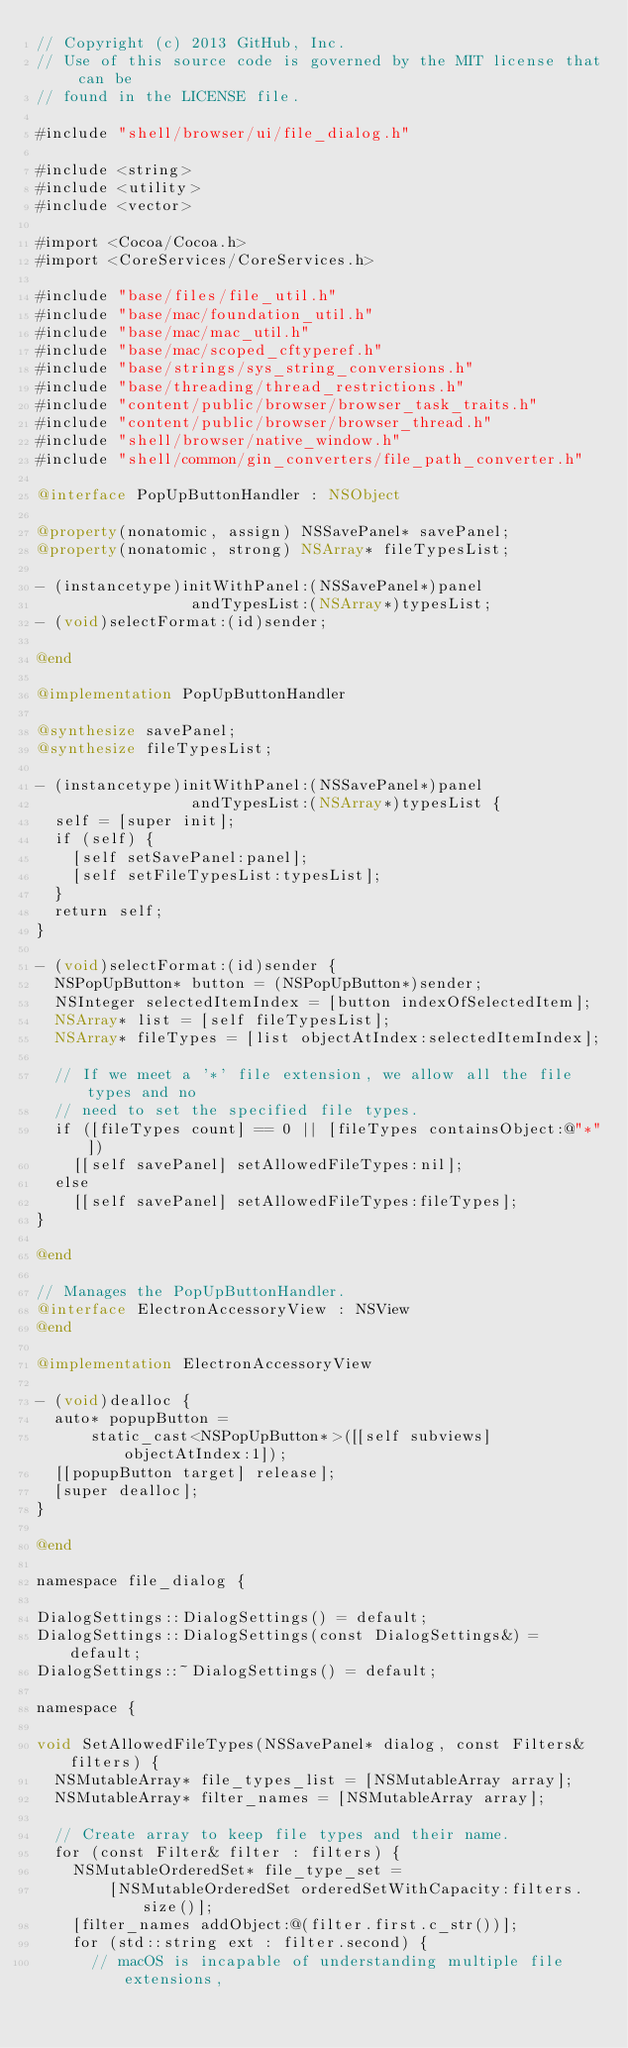Convert code to text. <code><loc_0><loc_0><loc_500><loc_500><_ObjectiveC_>// Copyright (c) 2013 GitHub, Inc.
// Use of this source code is governed by the MIT license that can be
// found in the LICENSE file.

#include "shell/browser/ui/file_dialog.h"

#include <string>
#include <utility>
#include <vector>

#import <Cocoa/Cocoa.h>
#import <CoreServices/CoreServices.h>

#include "base/files/file_util.h"
#include "base/mac/foundation_util.h"
#include "base/mac/mac_util.h"
#include "base/mac/scoped_cftyperef.h"
#include "base/strings/sys_string_conversions.h"
#include "base/threading/thread_restrictions.h"
#include "content/public/browser/browser_task_traits.h"
#include "content/public/browser/browser_thread.h"
#include "shell/browser/native_window.h"
#include "shell/common/gin_converters/file_path_converter.h"

@interface PopUpButtonHandler : NSObject

@property(nonatomic, assign) NSSavePanel* savePanel;
@property(nonatomic, strong) NSArray* fileTypesList;

- (instancetype)initWithPanel:(NSSavePanel*)panel
                 andTypesList:(NSArray*)typesList;
- (void)selectFormat:(id)sender;

@end

@implementation PopUpButtonHandler

@synthesize savePanel;
@synthesize fileTypesList;

- (instancetype)initWithPanel:(NSSavePanel*)panel
                 andTypesList:(NSArray*)typesList {
  self = [super init];
  if (self) {
    [self setSavePanel:panel];
    [self setFileTypesList:typesList];
  }
  return self;
}

- (void)selectFormat:(id)sender {
  NSPopUpButton* button = (NSPopUpButton*)sender;
  NSInteger selectedItemIndex = [button indexOfSelectedItem];
  NSArray* list = [self fileTypesList];
  NSArray* fileTypes = [list objectAtIndex:selectedItemIndex];

  // If we meet a '*' file extension, we allow all the file types and no
  // need to set the specified file types.
  if ([fileTypes count] == 0 || [fileTypes containsObject:@"*"])
    [[self savePanel] setAllowedFileTypes:nil];
  else
    [[self savePanel] setAllowedFileTypes:fileTypes];
}

@end

// Manages the PopUpButtonHandler.
@interface ElectronAccessoryView : NSView
@end

@implementation ElectronAccessoryView

- (void)dealloc {
  auto* popupButton =
      static_cast<NSPopUpButton*>([[self subviews] objectAtIndex:1]);
  [[popupButton target] release];
  [super dealloc];
}

@end

namespace file_dialog {

DialogSettings::DialogSettings() = default;
DialogSettings::DialogSettings(const DialogSettings&) = default;
DialogSettings::~DialogSettings() = default;

namespace {

void SetAllowedFileTypes(NSSavePanel* dialog, const Filters& filters) {
  NSMutableArray* file_types_list = [NSMutableArray array];
  NSMutableArray* filter_names = [NSMutableArray array];

  // Create array to keep file types and their name.
  for (const Filter& filter : filters) {
    NSMutableOrderedSet* file_type_set =
        [NSMutableOrderedSet orderedSetWithCapacity:filters.size()];
    [filter_names addObject:@(filter.first.c_str())];
    for (std::string ext : filter.second) {
      // macOS is incapable of understanding multiple file extensions,</code> 